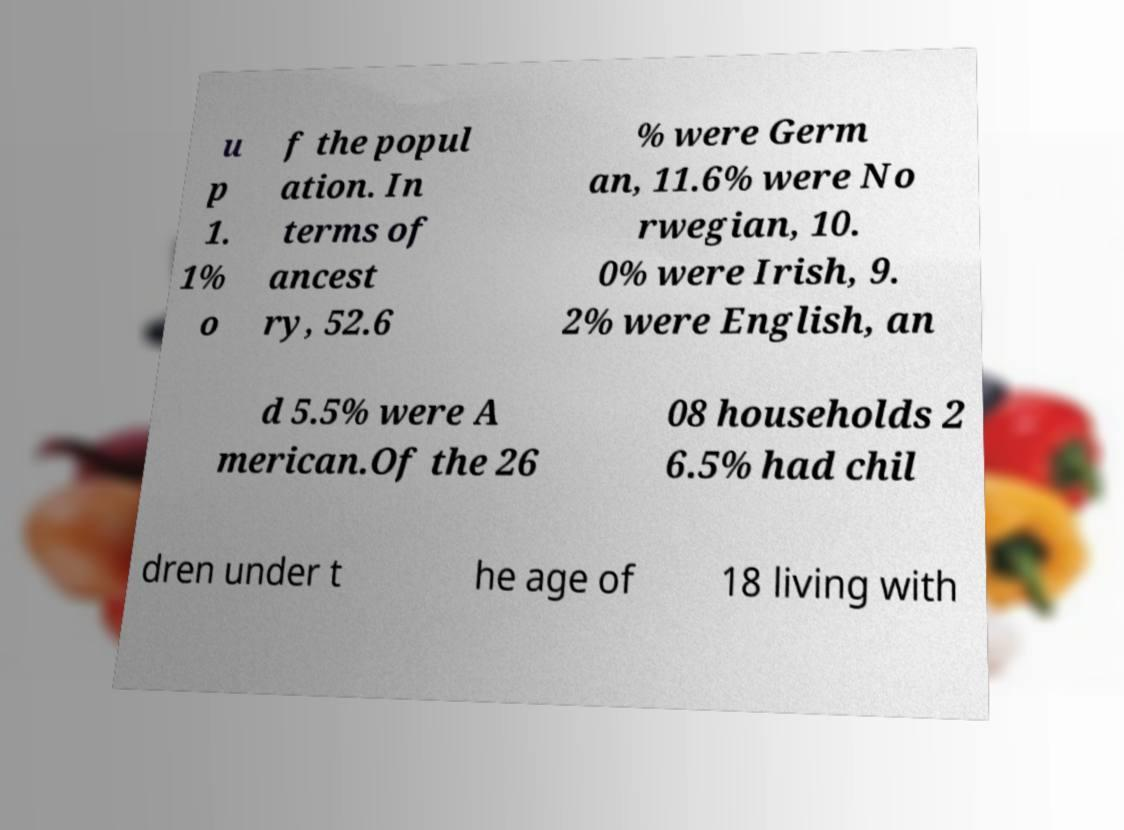Could you assist in decoding the text presented in this image and type it out clearly? u p 1. 1% o f the popul ation. In terms of ancest ry, 52.6 % were Germ an, 11.6% were No rwegian, 10. 0% were Irish, 9. 2% were English, an d 5.5% were A merican.Of the 26 08 households 2 6.5% had chil dren under t he age of 18 living with 